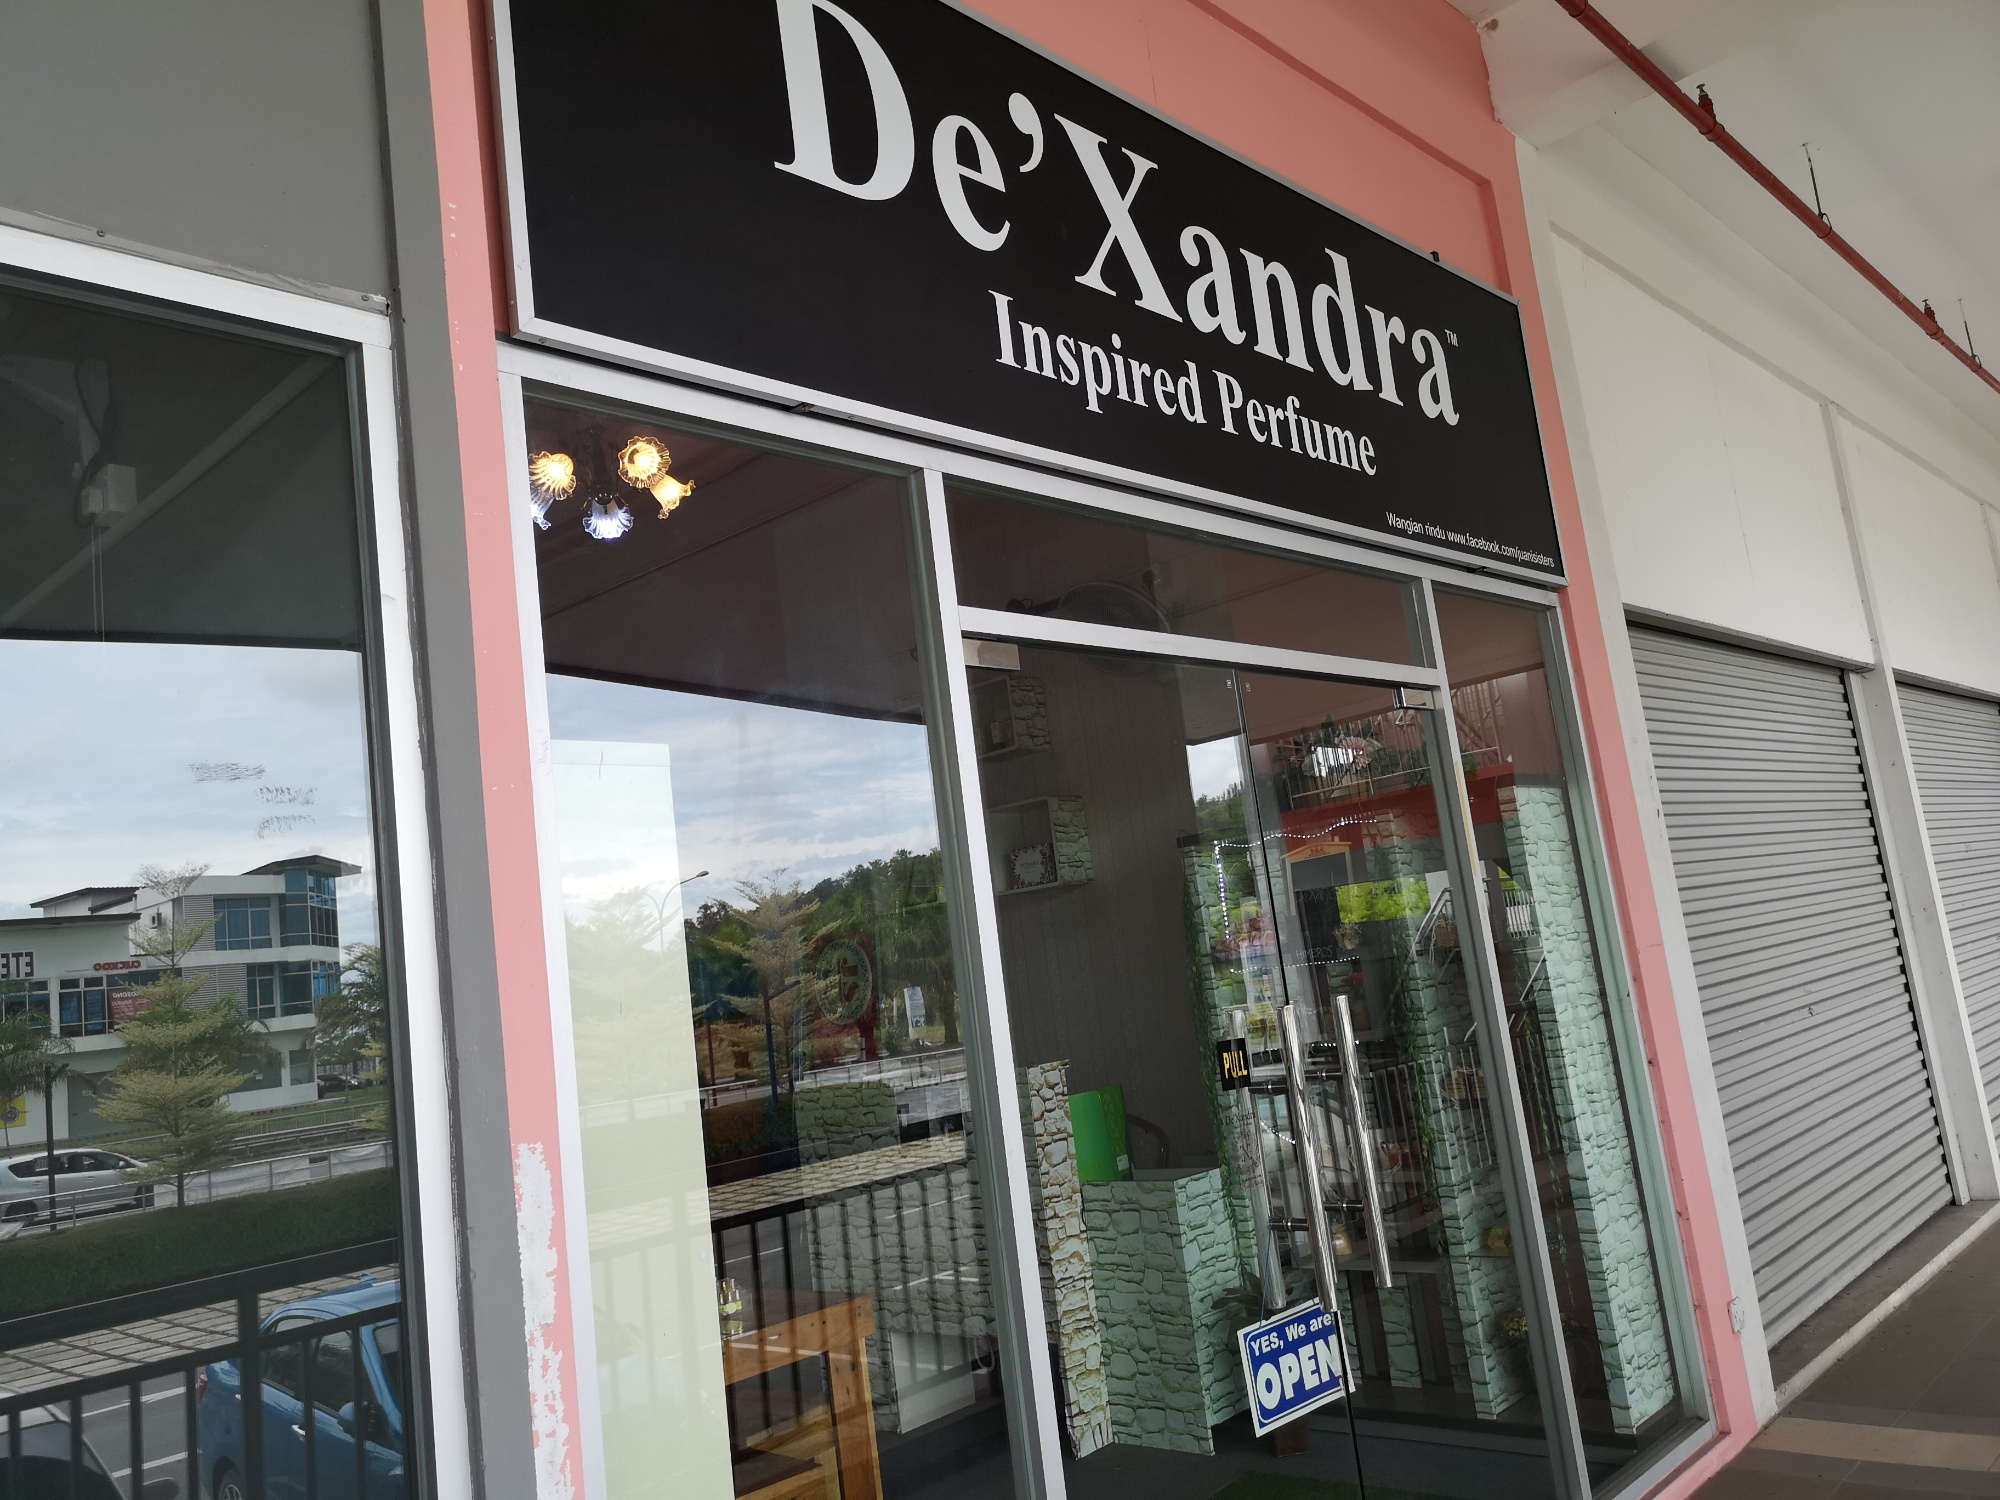Imagine this store is in a bustling futuristic city. Describe the changes you might see. In a bustling futuristic city, the De'Xandra store might sport interactive digital signage that changes colors and displays ads tailored to passersby. The glass windows could be smart glass that transitions from clear to opaque for privacy during special events or by customer request. Inside, shelves with holographic displays showcasing product details could replace traditional setups. Robots or AI assistants might help customers choose perfumes, and VR experiences could simulate different scents in various environments. The surrounding area might be a high-tech hub with automated valet services and green spaces integrated into city planning. The store would be a blend of cutting-edge technology and the timeless allure of perfume. 